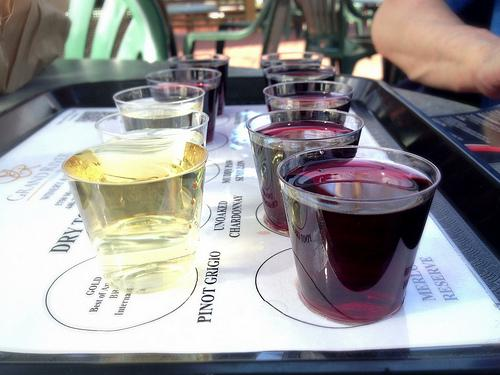Question: how many yellow liquid filled cups?
Choices:
A. One.
B. Three.
C. Two.
D. Five.
Answer with the letter. Answer: B Question: where are the drinks?
Choices:
A. On coasters.
B. On the table.
C. On a tray.
D. On the counter.
Answer with the letter. Answer: C Question: who is sitting?
Choices:
A. The old man.
B. The woman.
C. The person.
D. The toddler.
Answer with the letter. Answer: C Question: what color are the drinks on the right?
Choices:
A. Blue.
B. Pink.
C. Red.
D. Purple.
Answer with the letter. Answer: D 